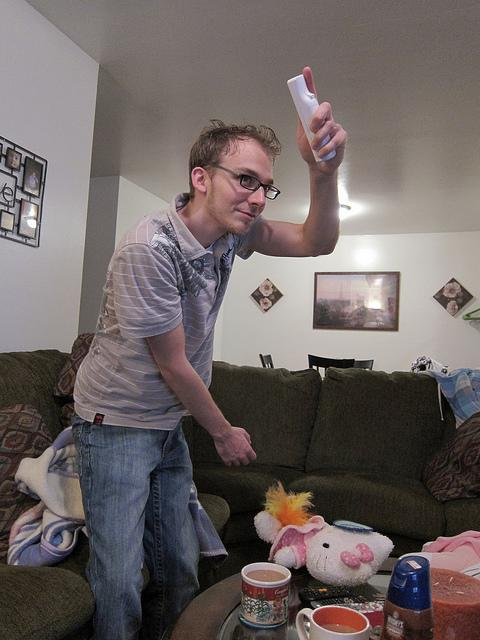What type of remote is the man holding?

Choices:
A) xbox
B) playstation 5
C) tv
D) nintendo wii nintendo wii 